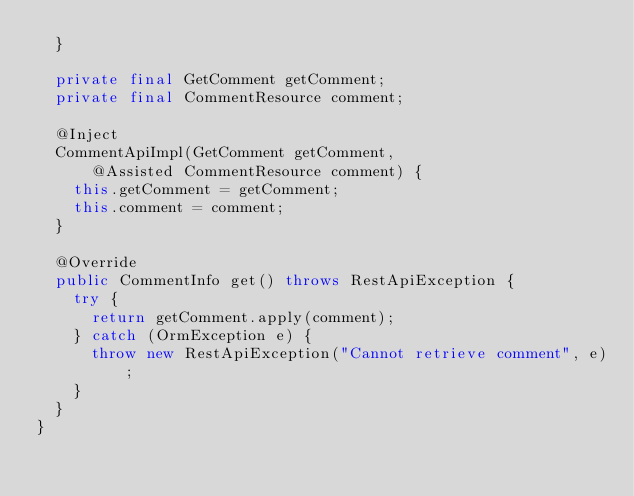<code> <loc_0><loc_0><loc_500><loc_500><_Java_>  }

  private final GetComment getComment;
  private final CommentResource comment;

  @Inject
  CommentApiImpl(GetComment getComment,
      @Assisted CommentResource comment) {
    this.getComment = getComment;
    this.comment = comment;
  }

  @Override
  public CommentInfo get() throws RestApiException {
    try {
      return getComment.apply(comment);
    } catch (OrmException e) {
      throw new RestApiException("Cannot retrieve comment", e);
    }
  }
}
</code> 